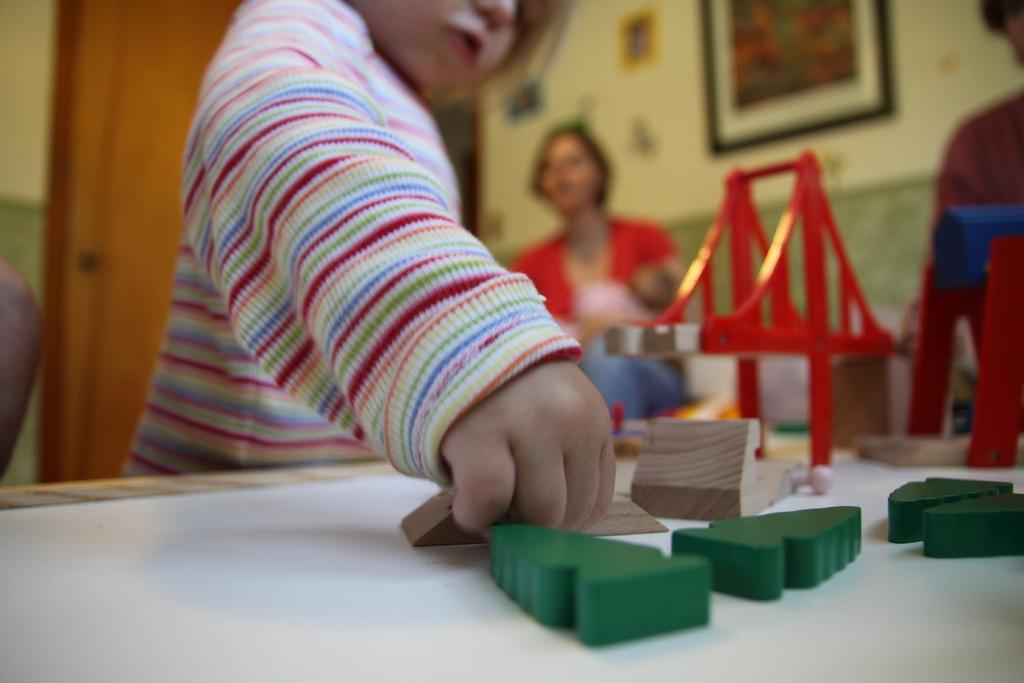Can you describe this image briefly? In this image I can see a baby is holding the toys which are placed on a table. In the background there is a person. At the back of her there is a wall along with the door and also I can see few frames are attached to the wall. 